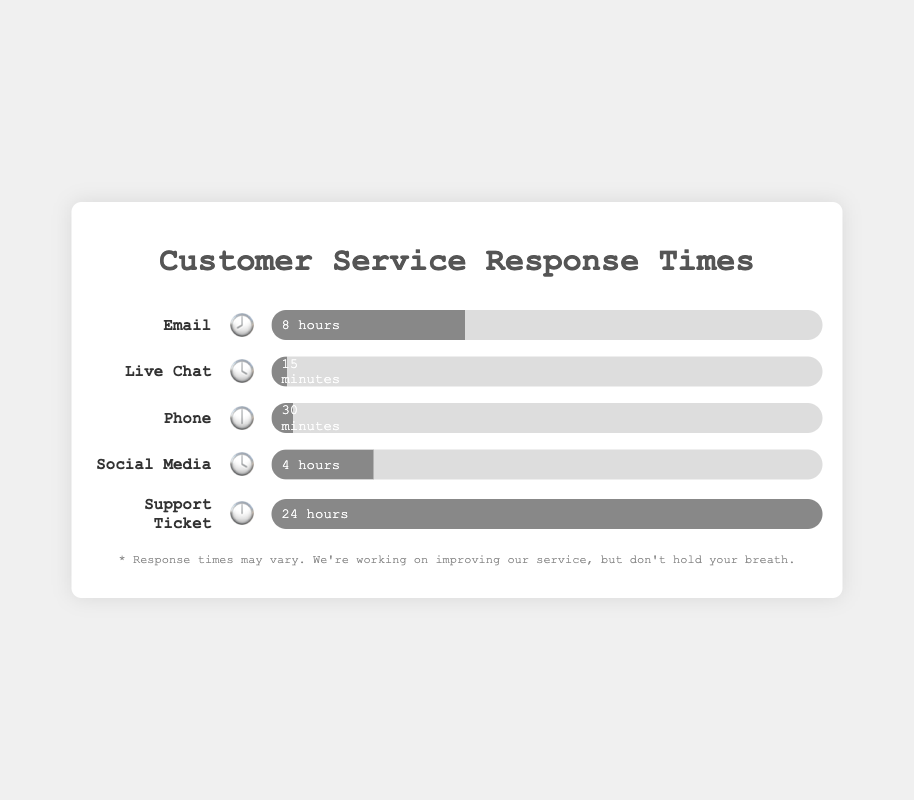Which channel has the fastest response time? The figure shows different channels with associated response times. The shortest bar indicates the fastest response time. According to the figure, Live Chat has the fastest response time, represented by the smallest bar (15 minutes).
Answer: Live Chat Which channel takes the longest to respond to customer inquiries? The figure presents response times with various lengths of bars. The channel with the longest bar signifies the longest response time. Support Ticket takes the longest, as indicated by the bar marked for 24 hours.
Answer: Support Ticket What is the combined response time for Phone and Social Media? The response time for Phone is 30 minutes and for Social Media is 4 hours. Convert both to hours (30 minutes = 0.5 hours). Then, sum the times: 0.5 + 4 = 4.5 hours.
Answer: 4.5 hours What is the difference in response time between Email and Live Chat? Email response time is 8 hours, while Live Chat is 15 minutes (which is 0.25 hours). Subtract the smaller from the larger: 8 - 0.25 = 7.75 hours.
Answer: 7.75 hours Which channel has a response time exactly half of the Email response time? Email response time is 8 hours. Half of 8 is 4 hours. According to the figure, Social Media's response time is 4 hours, making it the correct channel.
Answer: Social Media How many channels have response times less than 1 hour? The figure shows response times for each channel. Live Chat (15 minutes) and Phone (30 minutes) both have response times under 1 hour. Count these channels.
Answer: 2 How does the response time for Social Media compare to the response time for Phone? The response time for Social Media is 4 hours, and for Phone, it's 30 minutes. Convert 30 minutes to hours (0.5 hours). Since 4 hours is greater than 0.5 hours, Social Media has a longer response time.
Answer: Social Media is longer If Support Ticket response time improves by 50%, what would be the new response time? The current response time for Support Ticket is 24 hours. 50% improvement means it is cut in half: 24 hours / 2 = 12 hours.
Answer: 12 hours 